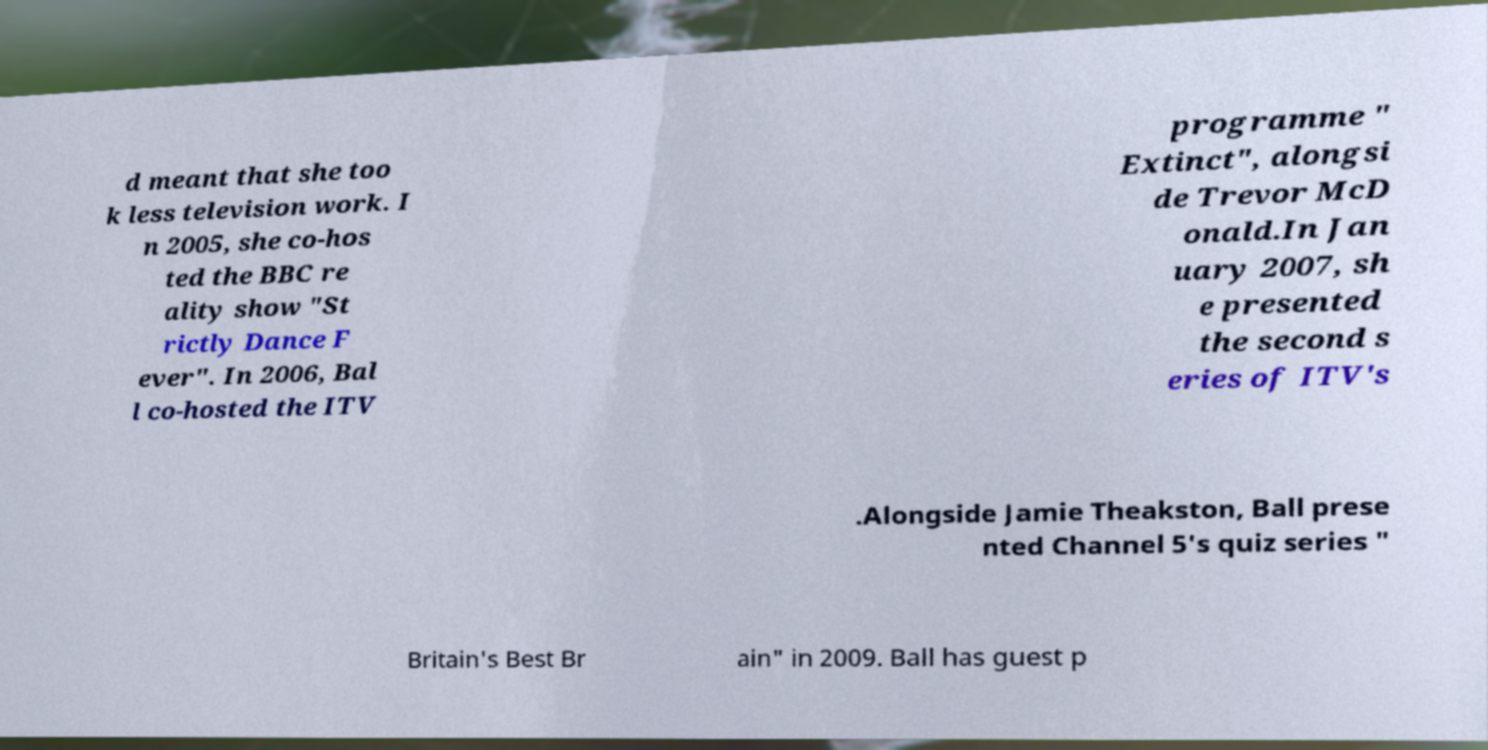I need the written content from this picture converted into text. Can you do that? d meant that she too k less television work. I n 2005, she co-hos ted the BBC re ality show "St rictly Dance F ever". In 2006, Bal l co-hosted the ITV programme " Extinct", alongsi de Trevor McD onald.In Jan uary 2007, sh e presented the second s eries of ITV's .Alongside Jamie Theakston, Ball prese nted Channel 5's quiz series " Britain's Best Br ain" in 2009. Ball has guest p 